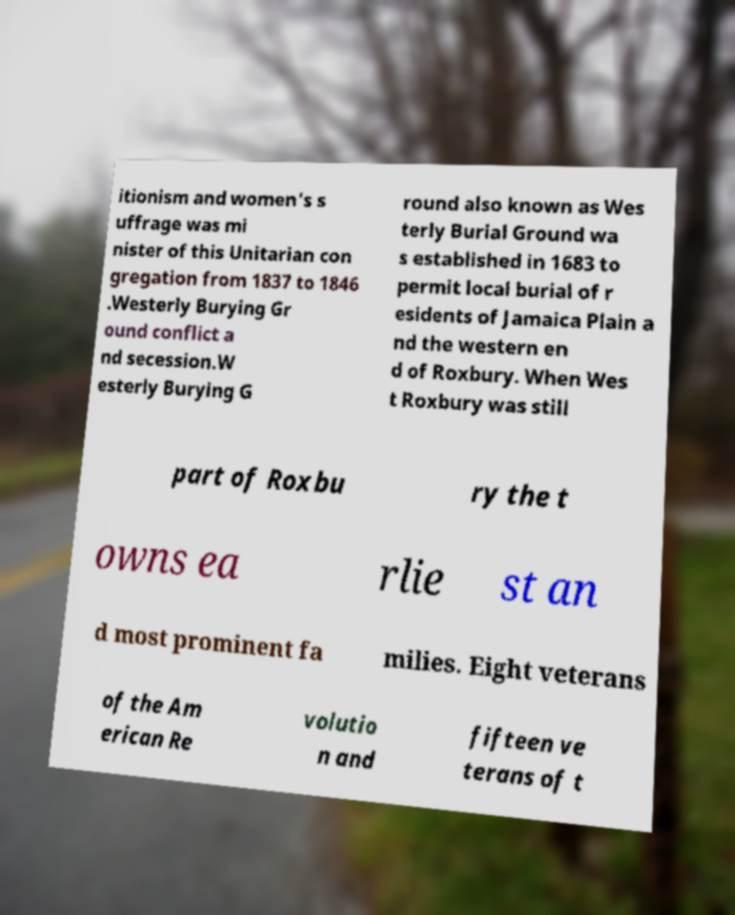There's text embedded in this image that I need extracted. Can you transcribe it verbatim? itionism and women's s uffrage was mi nister of this Unitarian con gregation from 1837 to 1846 .Westerly Burying Gr ound conflict a nd secession.W esterly Burying G round also known as Wes terly Burial Ground wa s established in 1683 to permit local burial of r esidents of Jamaica Plain a nd the western en d of Roxbury. When Wes t Roxbury was still part of Roxbu ry the t owns ea rlie st an d most prominent fa milies. Eight veterans of the Am erican Re volutio n and fifteen ve terans of t 